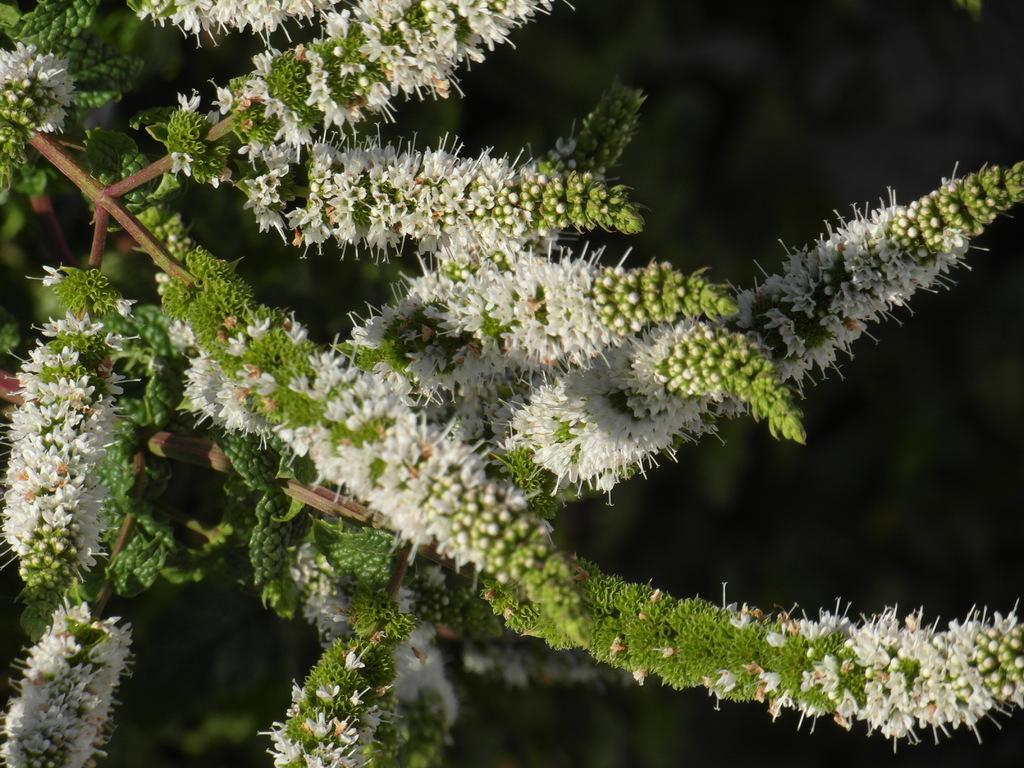What is the main subject in the front of the image? There is a plant in the front of the image. Can you describe the background of the image? The background of the image is blurry. How many beads are hanging from the plant in the image? There are no beads present in the image; it only features a plant. Is there a net visible in the background of the image? There is no net visible in the image; the background is blurry. 